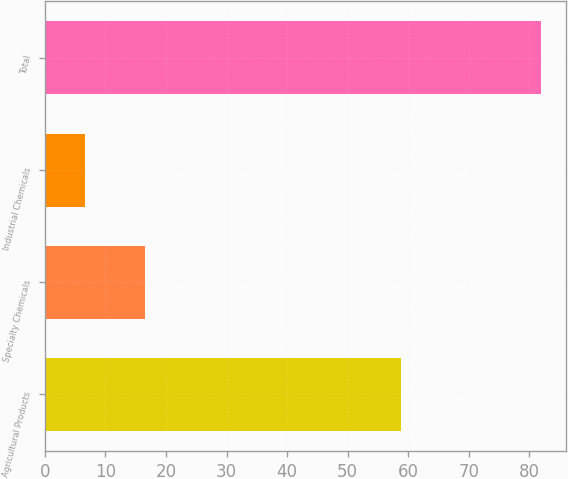Convert chart to OTSL. <chart><loc_0><loc_0><loc_500><loc_500><bar_chart><fcel>Agricultural Products<fcel>Specialty Chemicals<fcel>Industrial Chemicals<fcel>Total<nl><fcel>58.8<fcel>16.6<fcel>6.6<fcel>82<nl></chart> 